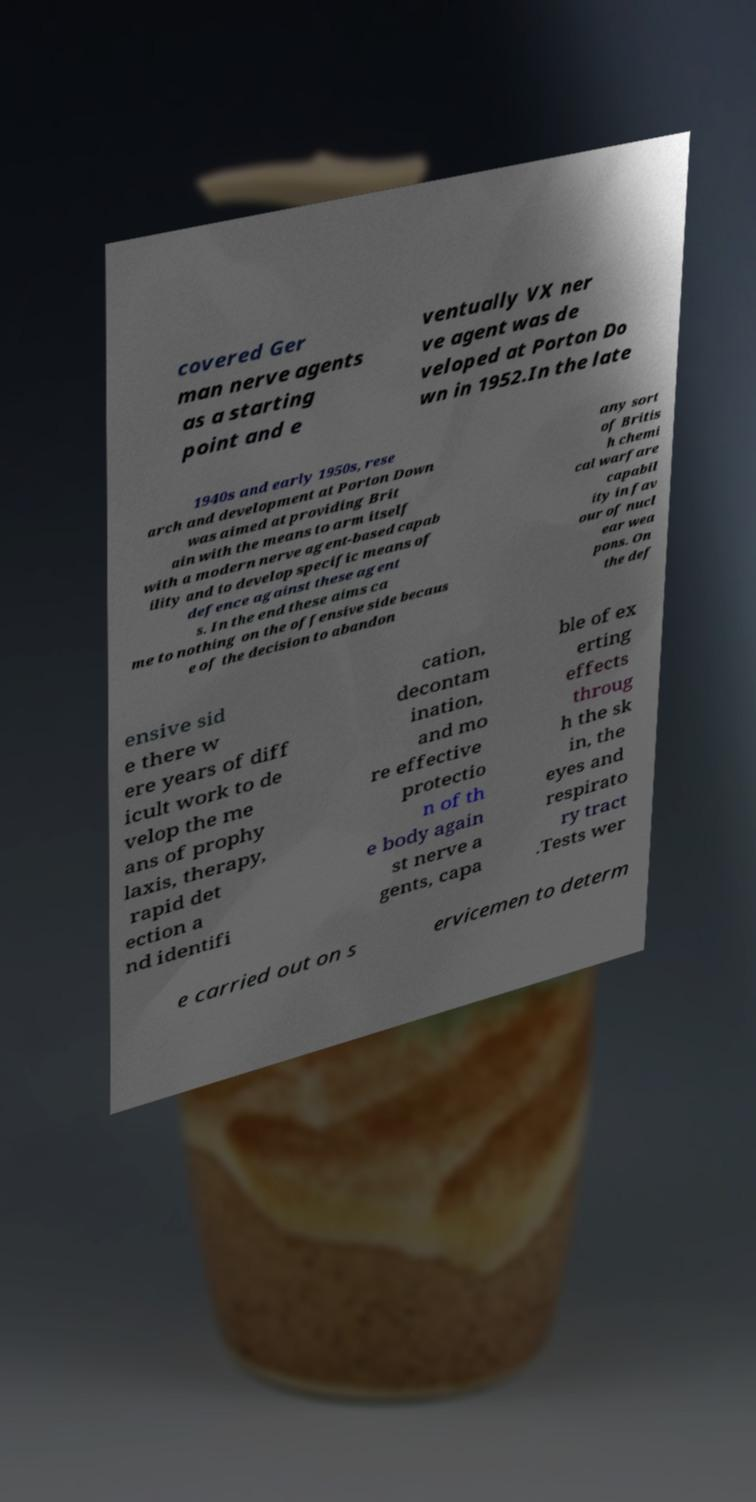I need the written content from this picture converted into text. Can you do that? covered Ger man nerve agents as a starting point and e ventually VX ner ve agent was de veloped at Porton Do wn in 1952.In the late 1940s and early 1950s, rese arch and development at Porton Down was aimed at providing Brit ain with the means to arm itself with a modern nerve agent-based capab ility and to develop specific means of defence against these agent s. In the end these aims ca me to nothing on the offensive side becaus e of the decision to abandon any sort of Britis h chemi cal warfare capabil ity in fav our of nucl ear wea pons. On the def ensive sid e there w ere years of diff icult work to de velop the me ans of prophy laxis, therapy, rapid det ection a nd identifi cation, decontam ination, and mo re effective protectio n of th e body again st nerve a gents, capa ble of ex erting effects throug h the sk in, the eyes and respirato ry tract .Tests wer e carried out on s ervicemen to determ 